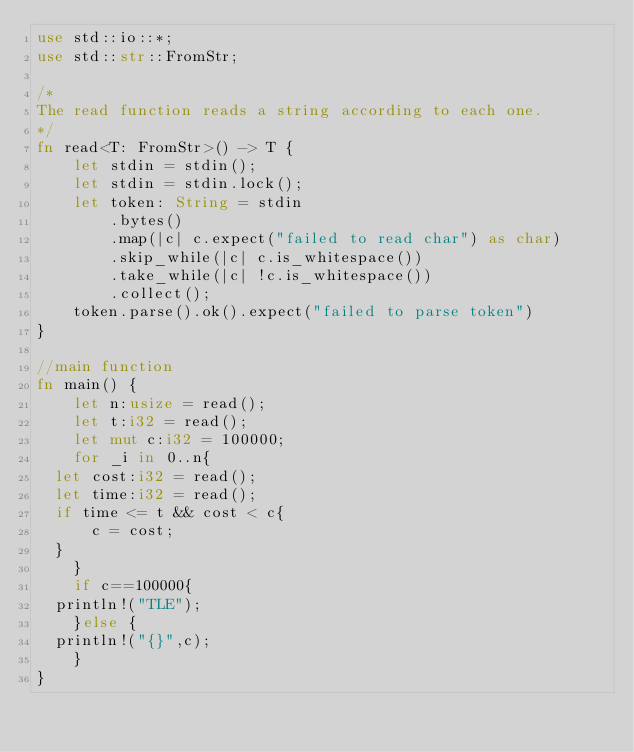Convert code to text. <code><loc_0><loc_0><loc_500><loc_500><_Rust_>use std::io::*;
use std::str::FromStr;
 
/* 
The read function reads a string according to each one. 
*/
fn read<T: FromStr>() -> T {
    let stdin = stdin();
    let stdin = stdin.lock();
    let token: String = stdin
        .bytes()
        .map(|c| c.expect("failed to read char") as char) 
        .skip_while(|c| c.is_whitespace())
        .take_while(|c| !c.is_whitespace())
        .collect();
    token.parse().ok().expect("failed to parse token")
}

//main function
fn main() {
    let n:usize = read();
    let t:i32 = read();
    let mut c:i32 = 100000;
    for _i in 0..n{
	let cost:i32 = read();
	let time:i32 = read();
	if time <= t && cost < c{
	    c = cost;
	}
    }
    if c==100000{
	println!("TLE");
    }else {
	println!("{}",c);
    }
}
</code> 